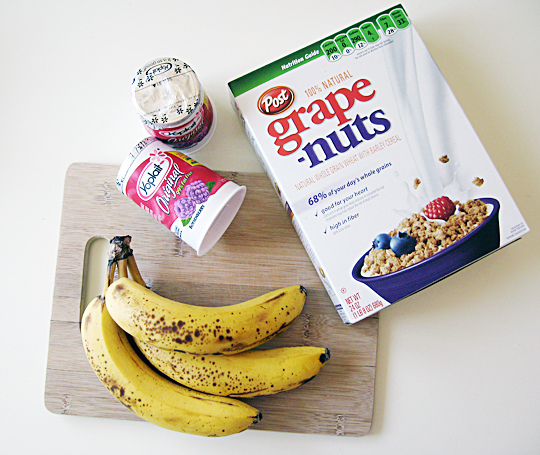Identify the text displayed in this image. nuts NATURAL grape Post yoplait 33 68% nuts 100% Original 